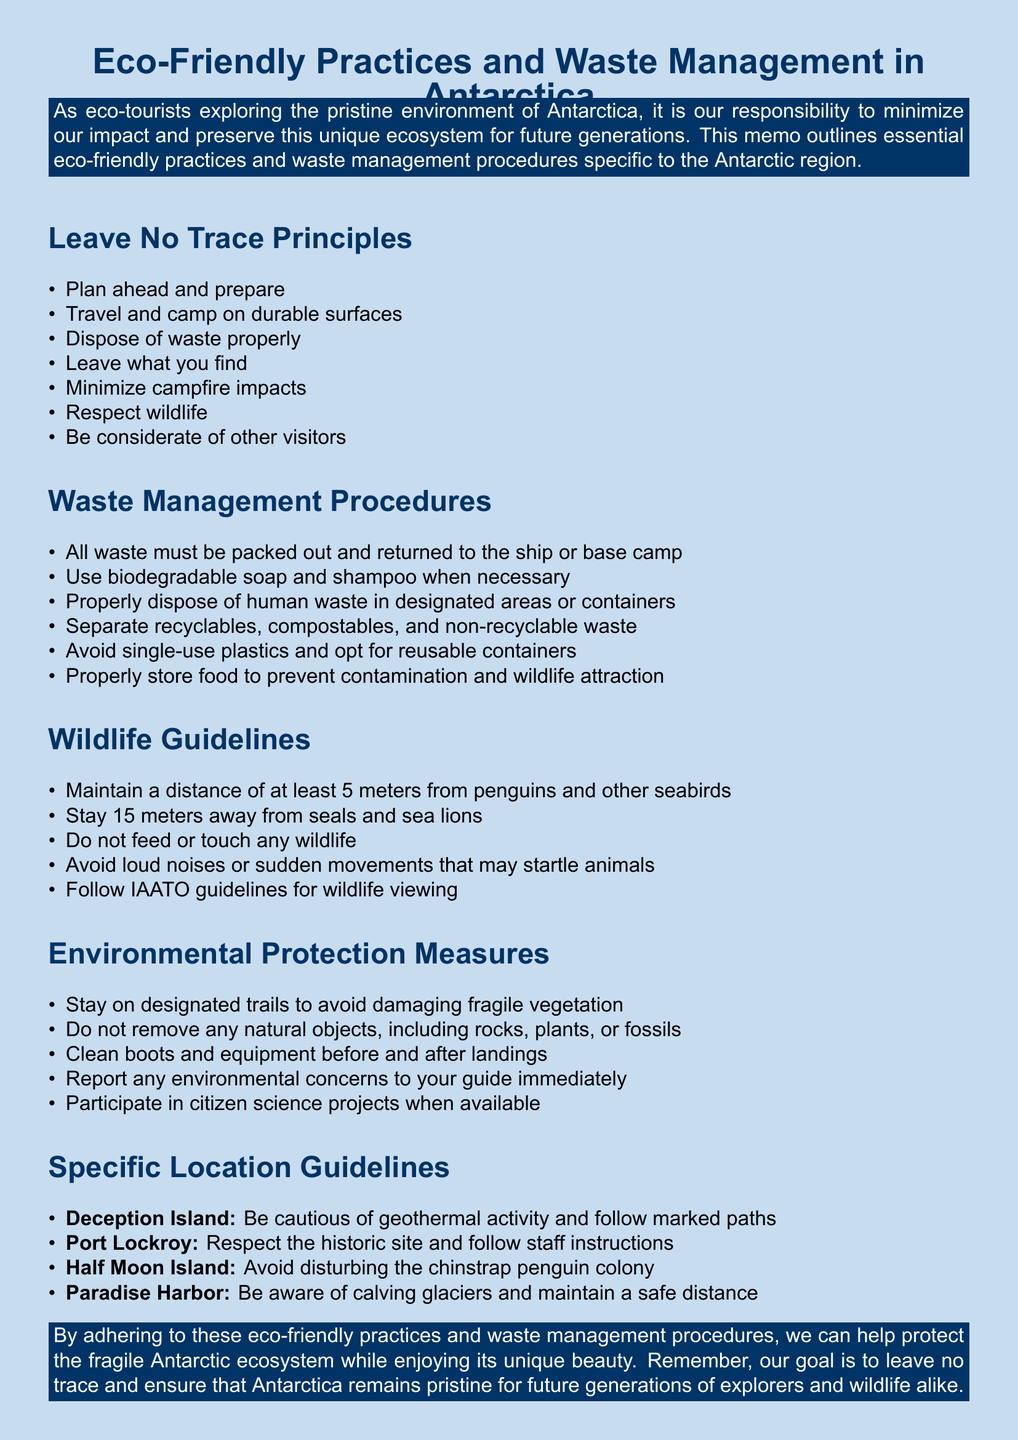What is the title of the memo? The title of the memo is stated at the top as "Eco-Friendly Practices and Waste Management in Antarctica."
Answer: Eco-Friendly Practices and Waste Management in Antarctica How many Leave No Trace Principles are listed? The document lists seven principles under Leave No Trace.
Answer: 7 What should you use when necessary for washing? The memo specifies to use biodegradable soap and shampoo when necessary.
Answer: Biodegradable soap and shampoo What is the recommended distance to maintain from seabirds? The document advises maintaining a distance of at least 5 meters from penguins and other seabirds.
Answer: 5 meters Which location requires caution due to geothermal activity? Deception Island is noted for requiring caution due to geothermal activity and following marked paths.
Answer: Deception Island How should human waste be disposed of? Human waste should be disposed of in designated areas or containers as per the waste management procedures.
Answer: Designated areas or containers What is the main goal stated in the conclusion? The main goal stated in the conclusion is to "leave no trace" and ensure Antarctica remains pristine.
Answer: Leave no trace What must be done if there is an environmental incident? The document instructs to report the environmental incident immediately to your guide and the expedition leader.
Answer: Report immediately to your guide and the expedition leader What is one of the specific location guidelines for Half Moon Island? The memo advises to avoid disturbing the chinstrap penguin colony at Half Moon Island.
Answer: Avoid disturbing the chinstrap penguin colony 